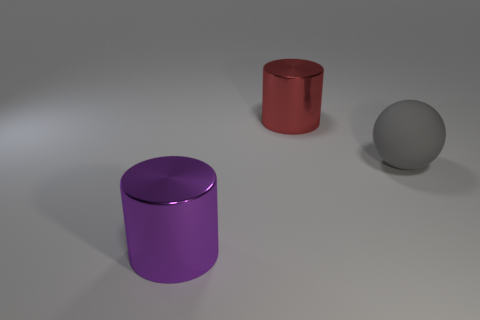Add 3 large things. How many objects exist? 6 Subtract all cylinders. How many objects are left? 1 Subtract 0 blue cylinders. How many objects are left? 3 Subtract all big red objects. Subtract all large purple things. How many objects are left? 1 Add 1 large shiny objects. How many large shiny objects are left? 3 Add 3 tiny gray metallic objects. How many tiny gray metallic objects exist? 3 